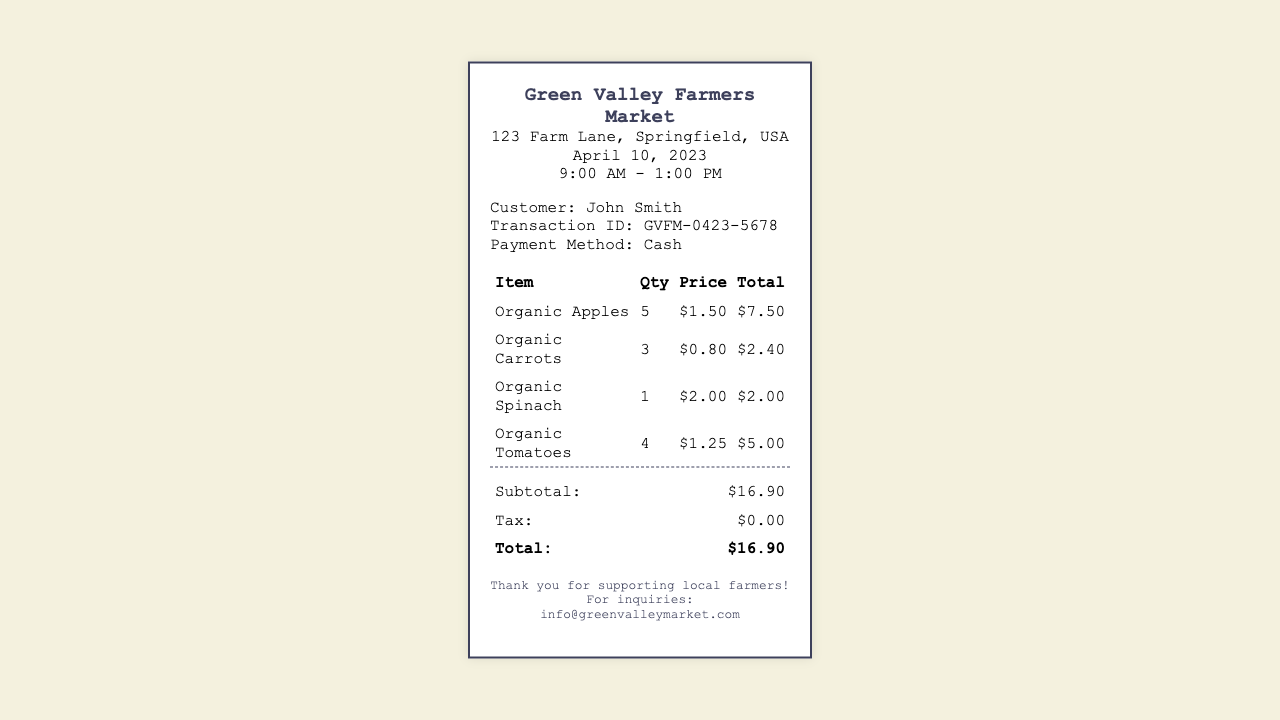What is the date of the transaction? The transaction date is explicitly stated in the document.
Answer: April 10, 2023 Who is the customer? The customer's name is provided in the transaction details section.
Answer: John Smith What is the total amount spent? The total amount is listed at the bottom of the receipt in the summary section.
Answer: $16.90 How many Organic Apples were purchased? The quantity of Organic Apples is mentioned in the itemized list of purchases.
Answer: 5 What method of payment was used? The payment method is clearly stated in the transaction details.
Answer: Cash What is the price of Organic Spinach? The price for Organic Spinach is listed in the itemized purchases.
Answer: $2.00 What is the subtotal before tax? The subtotal is provided in the summary section of the receipt.
Answer: $16.90 How many Organic Tomatoes were bought? The quantity of Organic Tomatoes is specified in the itemized list.
Answer: 4 What is the tax amount? The tax amount is indicated in the summary table of the document.
Answer: $0.00 